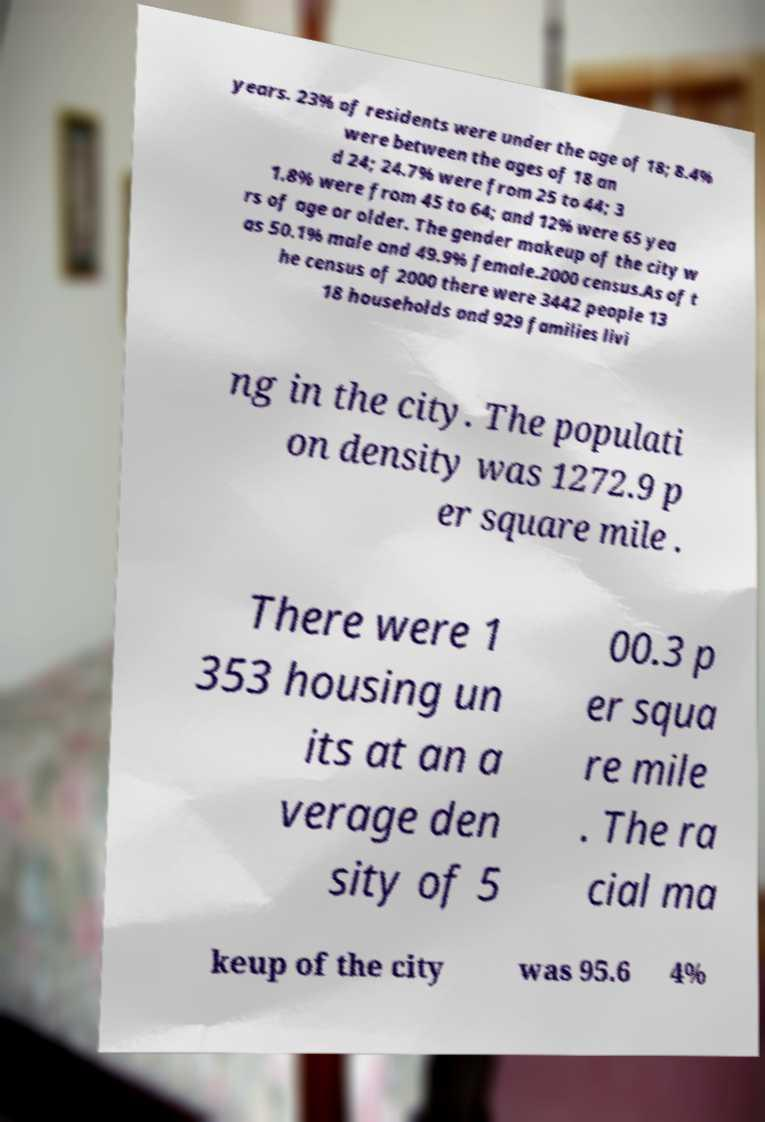Please read and relay the text visible in this image. What does it say? years. 23% of residents were under the age of 18; 8.4% were between the ages of 18 an d 24; 24.7% were from 25 to 44; 3 1.8% were from 45 to 64; and 12% were 65 yea rs of age or older. The gender makeup of the city w as 50.1% male and 49.9% female.2000 census.As of t he census of 2000 there were 3442 people 13 18 households and 929 families livi ng in the city. The populati on density was 1272.9 p er square mile . There were 1 353 housing un its at an a verage den sity of 5 00.3 p er squa re mile . The ra cial ma keup of the city was 95.6 4% 